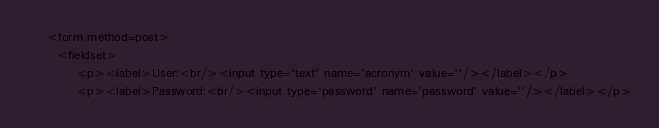<code> <loc_0><loc_0><loc_500><loc_500><_PHP_>
	<form method=post>
	  <fieldset>
		  <p><label>User:<br/><input type='text' name='acronym' value=''/></label></p>
		  <p><label>Password:<br/><input type='password' name='password' value=''/></label></p></code> 